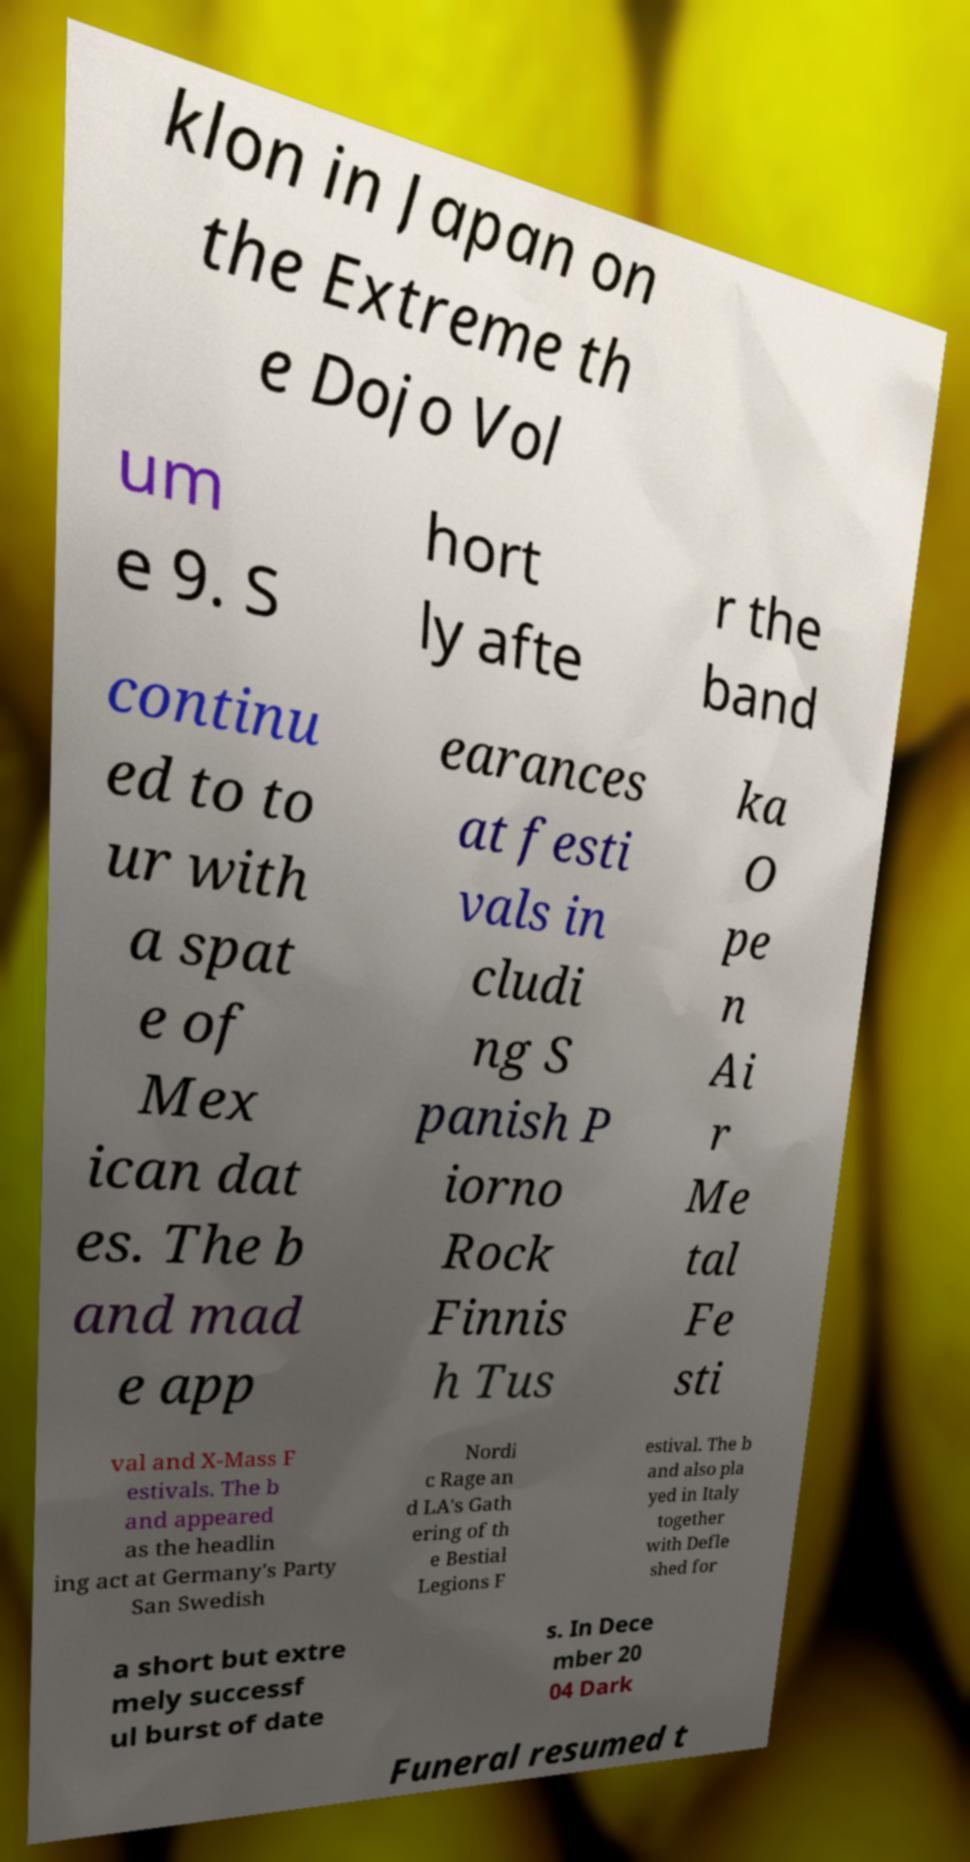Please read and relay the text visible in this image. What does it say? klon in Japan on the Extreme th e Dojo Vol um e 9. S hort ly afte r the band continu ed to to ur with a spat e of Mex ican dat es. The b and mad e app earances at festi vals in cludi ng S panish P iorno Rock Finnis h Tus ka O pe n Ai r Me tal Fe sti val and X-Mass F estivals. The b and appeared as the headlin ing act at Germany's Party San Swedish Nordi c Rage an d LA's Gath ering of th e Bestial Legions F estival. The b and also pla yed in Italy together with Defle shed for a short but extre mely successf ul burst of date s. In Dece mber 20 04 Dark Funeral resumed t 